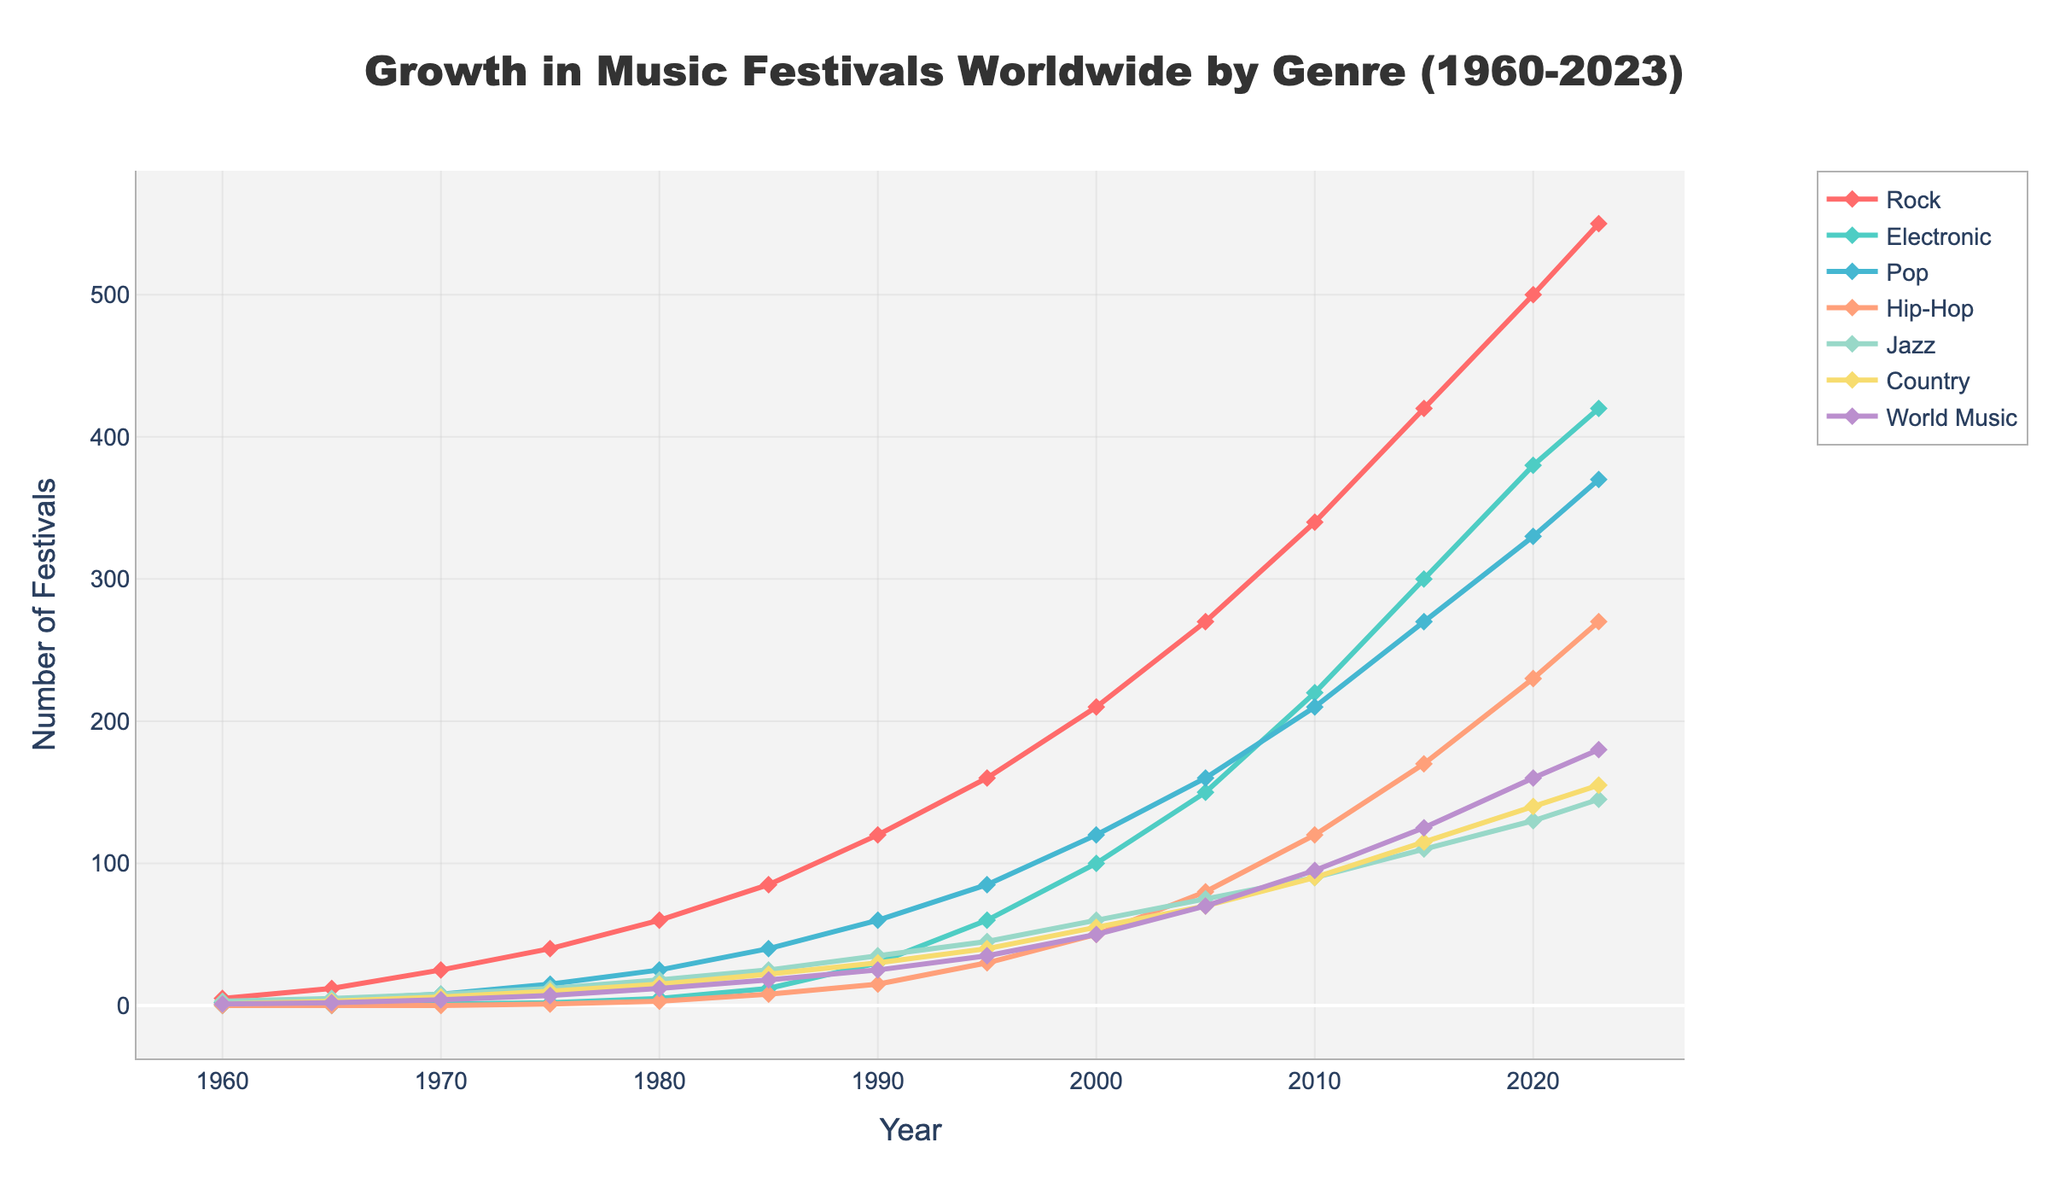When did Rock music festivals see their most significant growth period? The period of the most significant growth can be identified by the steepest increase on the Rock line. This is between 1985 and 1990, where the number of festivals grew from 85 to 120.
Answer: 1985-1990 Which genre had the highest number of festivals in 2023? By looking at the endpoints of the lines on the graph for the year 2023, Rock, which ends at 550, is the highest.
Answer: Rock How many music festivals were there in total across all genres in 1985? Add the number of festivals for all genres in 1985: Rock (85) + Electronic (12) + Pop (40) + Hip-Hop (8) + Jazz (25) + Country (22) + World Music (18) = 210.
Answer: 210 Between which years did Electronic music festivals experience their fastest growth? Identify the steepest slope on the Electronic line. The period from 2000 to 2005 shows the fastest growth from 100 to 150 festivals.
Answer: 2000-2005 What is the difference in the number of Jazz festivals between 1960 and 2023? Subtract the number of Jazz festivals in 1960 (3) from the number in 2023 (145). 145 - 3 = 142.
Answer: 142 Which two genres had the closest number of festivals in 2015? Check the 2015 data points and compare: Pop (270) and Country (115) had a difference of 155, Jazz (110), World Music (125) had a difference of 15. Therefore, Jazz (110) and World Music (125) are closest.
Answer: Jazz and World Music What is the average number of Hip-Hop festivals in the years 2005, 2010, and 2015? Sum the numbers of Hip-Hop festivals for 2005 (80), 2010 (120), and 2015 (170), then divide by 3. The sum is 370; 370/3 = 123.33 repeating.
Answer: 123.33 Which genre had a slower growth rate, Country or Pop, during the period 1960-1980? Compare the increase in the number of festivals for each genre from 1960 to 1980. Country went from 1 to 15 (+14) and Pop from 2 to 25 (+23). Therefore, Country had a slower growth rate.
Answer: Country 